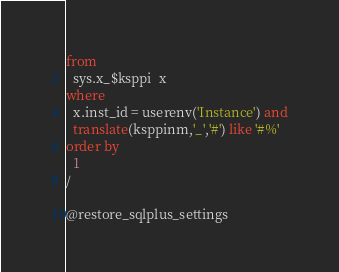<code> <loc_0><loc_0><loc_500><loc_500><_SQL_>from
  sys.x_$ksppi  x
where
  x.inst_id = userenv('Instance') and
  translate(ksppinm,'_','#') like '#%'
order by
  1
/

@restore_sqlplus_settings
</code> 